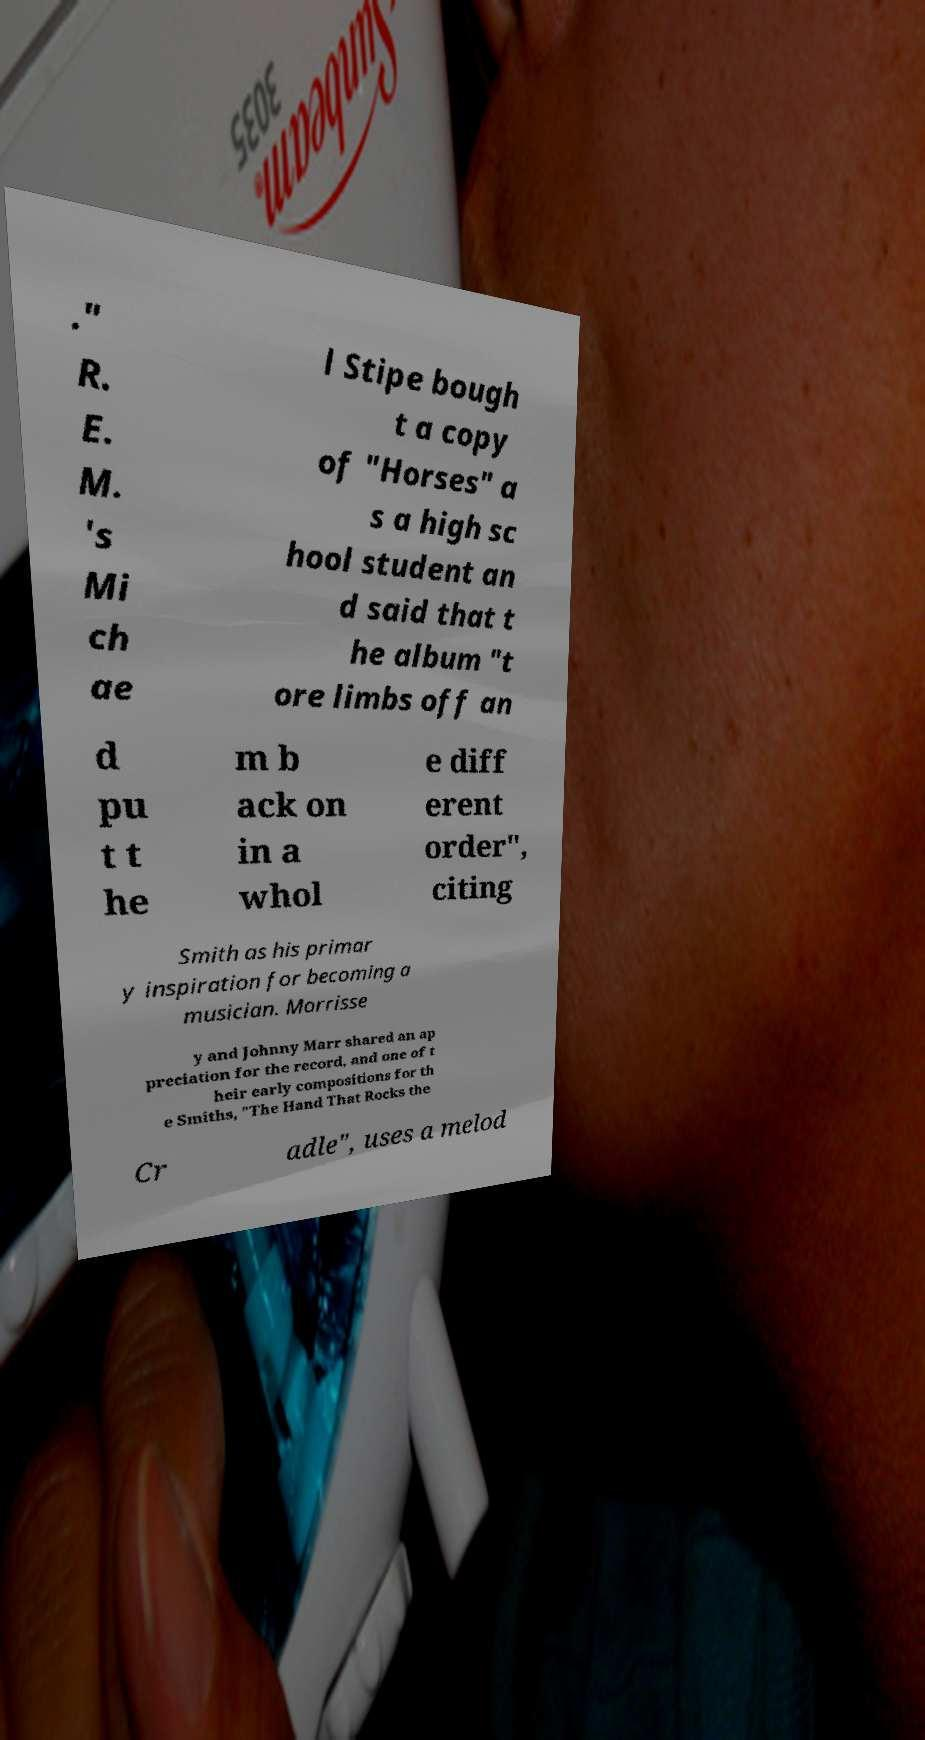Can you accurately transcribe the text from the provided image for me? ." R. E. M. 's Mi ch ae l Stipe bough t a copy of "Horses" a s a high sc hool student an d said that t he album "t ore limbs off an d pu t t he m b ack on in a whol e diff erent order", citing Smith as his primar y inspiration for becoming a musician. Morrisse y and Johnny Marr shared an ap preciation for the record, and one of t heir early compositions for th e Smiths, "The Hand That Rocks the Cr adle", uses a melod 